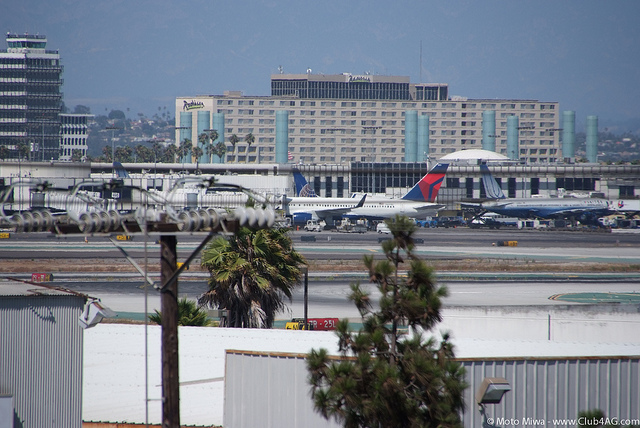Identify the text displayed in this image. www.Club4AG.com Moto 